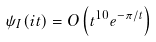<formula> <loc_0><loc_0><loc_500><loc_500>\psi _ { I } ( i t ) = O \left ( t ^ { 1 0 } e ^ { - \pi / t } \right )</formula> 